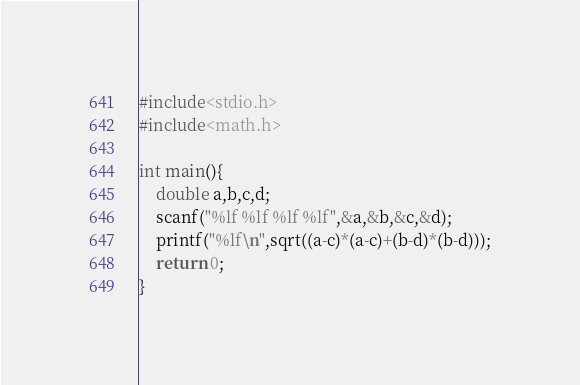<code> <loc_0><loc_0><loc_500><loc_500><_C_>#include<stdio.h>
#include<math.h>

int main(){
	double a,b,c,d;
	scanf("%lf %lf %lf %lf",&a,&b,&c,&d);
	printf("%lf\n",sqrt((a-c)*(a-c)+(b-d)*(b-d)));
	return 0;
}</code> 